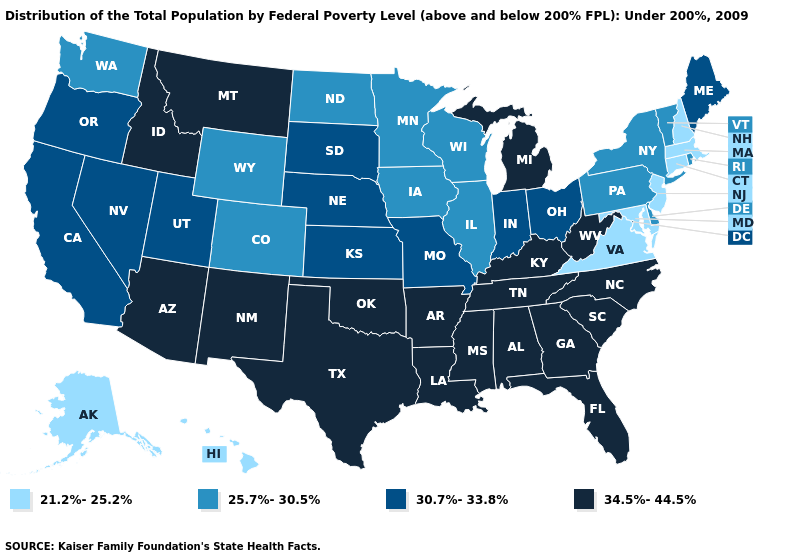Does the map have missing data?
Give a very brief answer. No. What is the lowest value in the South?
Give a very brief answer. 21.2%-25.2%. What is the value of Idaho?
Concise answer only. 34.5%-44.5%. Name the states that have a value in the range 34.5%-44.5%?
Give a very brief answer. Alabama, Arizona, Arkansas, Florida, Georgia, Idaho, Kentucky, Louisiana, Michigan, Mississippi, Montana, New Mexico, North Carolina, Oklahoma, South Carolina, Tennessee, Texas, West Virginia. Among the states that border Virginia , which have the highest value?
Short answer required. Kentucky, North Carolina, Tennessee, West Virginia. Does Washington have the highest value in the USA?
Answer briefly. No. What is the highest value in the USA?
Concise answer only. 34.5%-44.5%. Name the states that have a value in the range 21.2%-25.2%?
Keep it brief. Alaska, Connecticut, Hawaii, Maryland, Massachusetts, New Hampshire, New Jersey, Virginia. Which states have the lowest value in the MidWest?
Keep it brief. Illinois, Iowa, Minnesota, North Dakota, Wisconsin. Name the states that have a value in the range 34.5%-44.5%?
Write a very short answer. Alabama, Arizona, Arkansas, Florida, Georgia, Idaho, Kentucky, Louisiana, Michigan, Mississippi, Montana, New Mexico, North Carolina, Oklahoma, South Carolina, Tennessee, Texas, West Virginia. What is the value of Delaware?
Keep it brief. 25.7%-30.5%. Does Virginia have the lowest value in the USA?
Be succinct. Yes. Name the states that have a value in the range 21.2%-25.2%?
Give a very brief answer. Alaska, Connecticut, Hawaii, Maryland, Massachusetts, New Hampshire, New Jersey, Virginia. How many symbols are there in the legend?
Answer briefly. 4. 